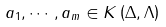<formula> <loc_0><loc_0><loc_500><loc_500>a _ { 1 } , \cdots , a _ { m } \in K \left ( \Delta , \Lambda \right )</formula> 